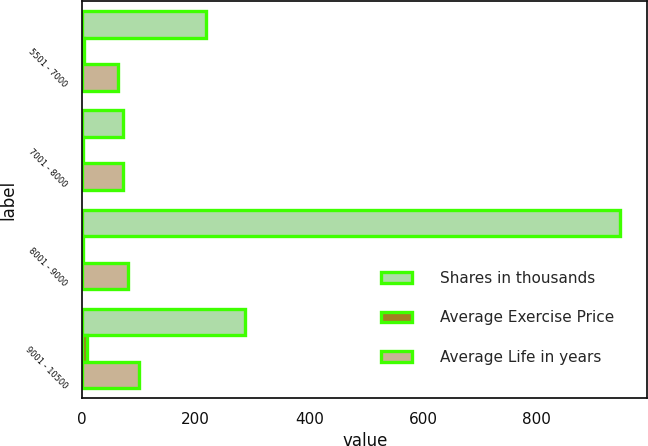Convert chart to OTSL. <chart><loc_0><loc_0><loc_500><loc_500><stacked_bar_chart><ecel><fcel>5501 - 7000<fcel>7001 - 8000<fcel>8001 - 9000<fcel>9001 - 10500<nl><fcel>Shares in thousands<fcel>218<fcel>72.14<fcel>947<fcel>286<nl><fcel>Average Exercise Price<fcel>3.94<fcel>2.53<fcel>1.52<fcel>8.74<nl><fcel>Average Life in years<fcel>62.48<fcel>72.14<fcel>81.23<fcel>99.75<nl></chart> 